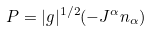Convert formula to latex. <formula><loc_0><loc_0><loc_500><loc_500>P = | g | ^ { 1 / 2 } ( - J ^ { \alpha } n _ { \alpha } )</formula> 